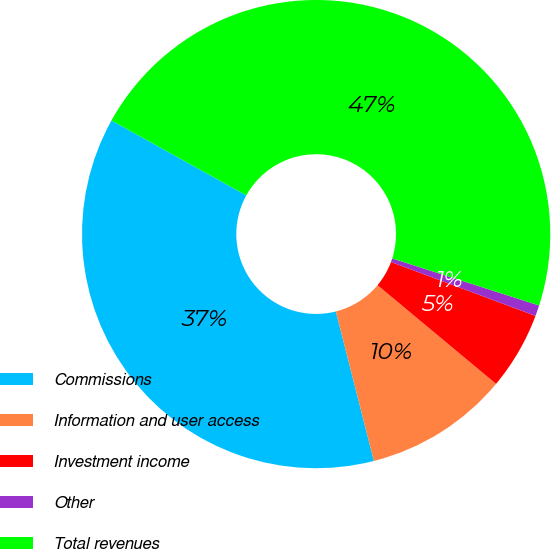<chart> <loc_0><loc_0><loc_500><loc_500><pie_chart><fcel>Commissions<fcel>Information and user access<fcel>Investment income<fcel>Other<fcel>Total revenues<nl><fcel>37.03%<fcel>9.98%<fcel>5.37%<fcel>0.75%<fcel>46.87%<nl></chart> 